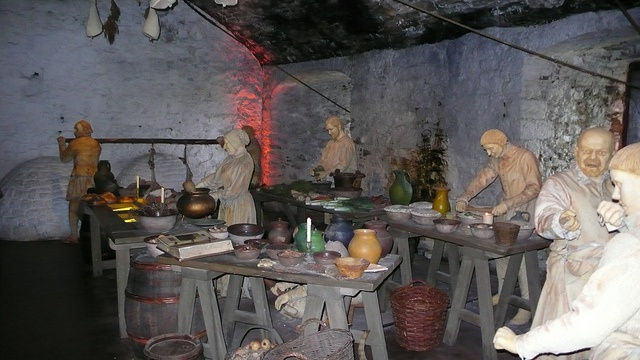Describe the objects in this image and their specific colors. I can see dining table in purple, gray, black, and darkgray tones, dining table in purple, gray, and black tones, people in purple, darkgray, lightgray, and tan tones, dining table in purple, black, gray, and olive tones, and vase in purple, tan, gray, and olive tones in this image. 